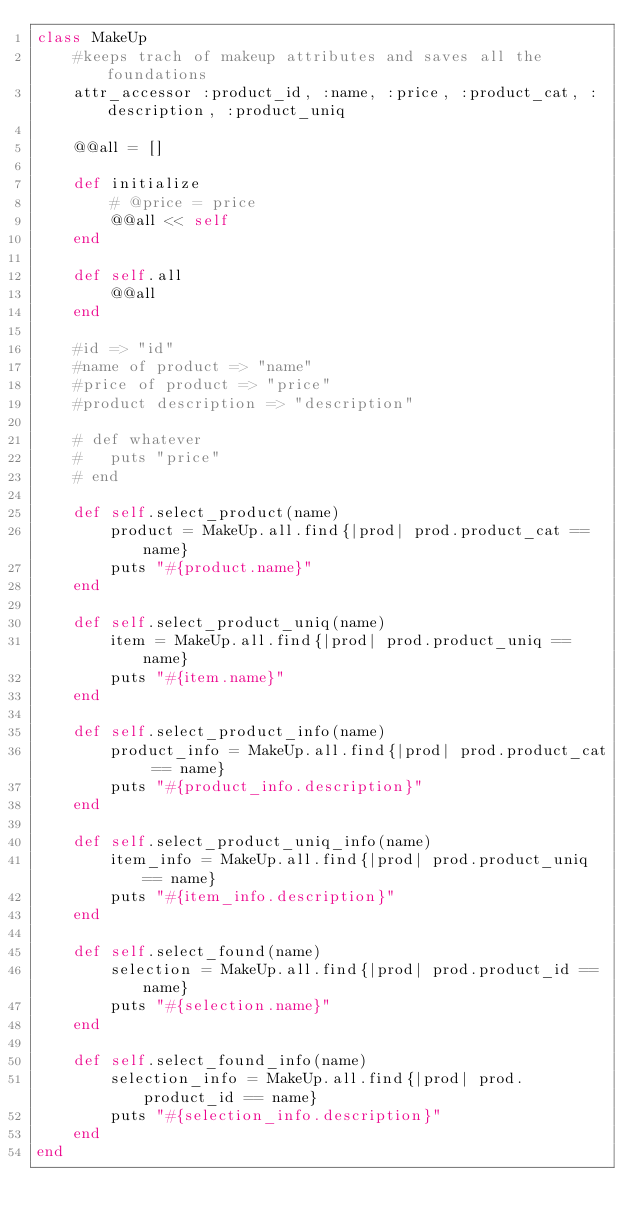Convert code to text. <code><loc_0><loc_0><loc_500><loc_500><_Ruby_>class MakeUp 
    #keeps trach of makeup attributes and saves all the foundations 
    attr_accessor :product_id, :name, :price, :product_cat, :description, :product_uniq
    
    @@all = []
    
    def initialize
        # @price = price
        @@all << self
    end

    def self.all
        @@all
    end

    #id => "id"
    #name of product => "name"
    #price of product => "price"
    #product description => "description"

    # def whatever
    #   puts "price"
    # end

    def self.select_product(name)
        product = MakeUp.all.find{|prod| prod.product_cat == name}
        puts "#{product.name}"
    end 

    def self.select_product_uniq(name)
        item = MakeUp.all.find{|prod| prod.product_uniq == name}
        puts "#{item.name}"
    end 

    def self.select_product_info(name)
        product_info = MakeUp.all.find{|prod| prod.product_cat == name}
        puts "#{product_info.description}"
    end 

    def self.select_product_uniq_info(name)
        item_info = MakeUp.all.find{|prod| prod.product_uniq == name}
        puts "#{item_info.description}"
    end

    def self.select_found(name)
        selection = MakeUp.all.find{|prod| prod.product_id == name}
        puts "#{selection.name}"
    end 

    def self.select_found_info(name)
        selection_info = MakeUp.all.find{|prod| prod.product_id == name}
        puts "#{selection_info.description}"
    end 
end 
</code> 